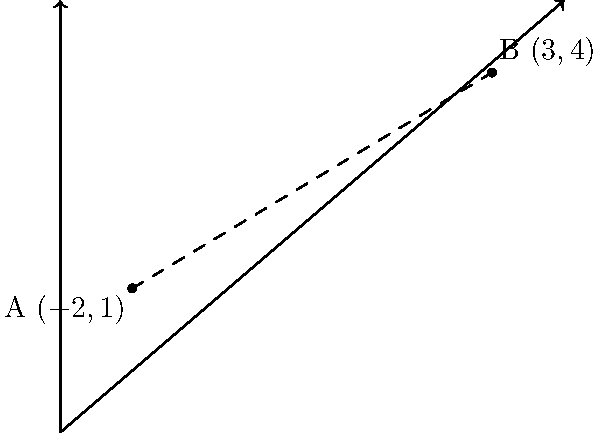You're planning a route to visit two community centers in your new neighborhood. On a map with a coordinate system, the first center (A) is located at $(-2,1)$, and the second center (B) is at $(3,4)$. Calculate the straight-line distance between these two centers. To find the distance between two points on a coordinate plane, we can use the distance formula:

$$d = \sqrt{(x_2-x_1)^2 + (y_2-y_1)^2}$$

Where $(x_1,y_1)$ are the coordinates of the first point and $(x_2,y_2)$ are the coordinates of the second point.

Step 1: Identify the coordinates
Point A: $(-2,1)$, so $x_1=-2$ and $y_1=1$
Point B: $(3,4)$, so $x_2=3$ and $y_2=4$

Step 2: Plug these values into the distance formula
$$d = \sqrt{(3-(-2))^2 + (4-1)^2}$$

Step 3: Simplify inside the parentheses
$$d = \sqrt{(3+2)^2 + (3)^2}$$
$$d = \sqrt{5^2 + 3^2}$$

Step 4: Calculate the squares
$$d = \sqrt{25 + 9}$$

Step 5: Add under the square root
$$d = \sqrt{34}$$

Step 6: Simplify if possible (in this case, $\sqrt{34}$ cannot be simplified further)

Therefore, the distance between the two community centers is $\sqrt{34}$ units.
Answer: $\sqrt{34}$ units 